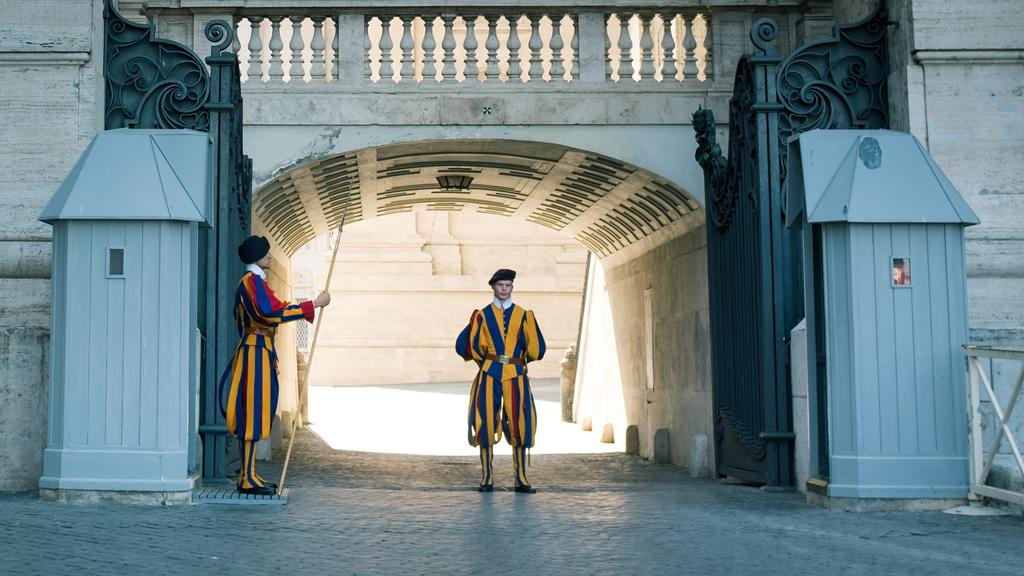How many people are in the image? There are two men in the image. Where are the men located in the image? The men are standing near the entrance. What colors are the men wearing? Both men are wearing yellow and blue color dresses. What type of noise can be heard coming from the boundary in the image? There is no boundary present in the image, and therefore no noise can be heard coming from it. 